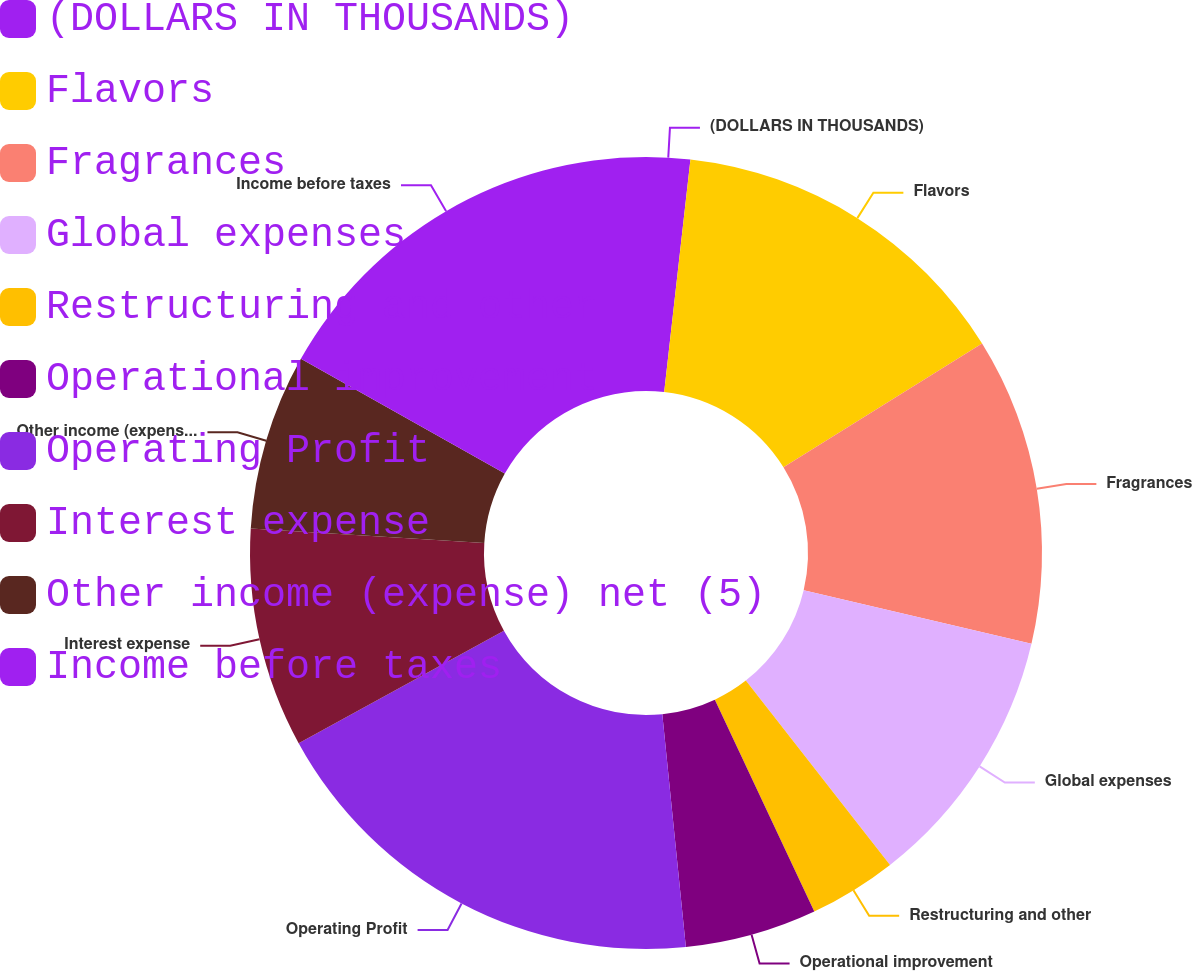Convert chart to OTSL. <chart><loc_0><loc_0><loc_500><loc_500><pie_chart><fcel>(DOLLARS IN THOUSANDS)<fcel>Flavors<fcel>Fragrances<fcel>Global expenses<fcel>Restructuring and other<fcel>Operational improvement<fcel>Operating Profit<fcel>Interest expense<fcel>Other income (expense) net (5)<fcel>Income before taxes<nl><fcel>1.79%<fcel>14.34%<fcel>12.55%<fcel>10.75%<fcel>3.58%<fcel>5.38%<fcel>18.63%<fcel>8.96%<fcel>7.17%<fcel>16.84%<nl></chart> 